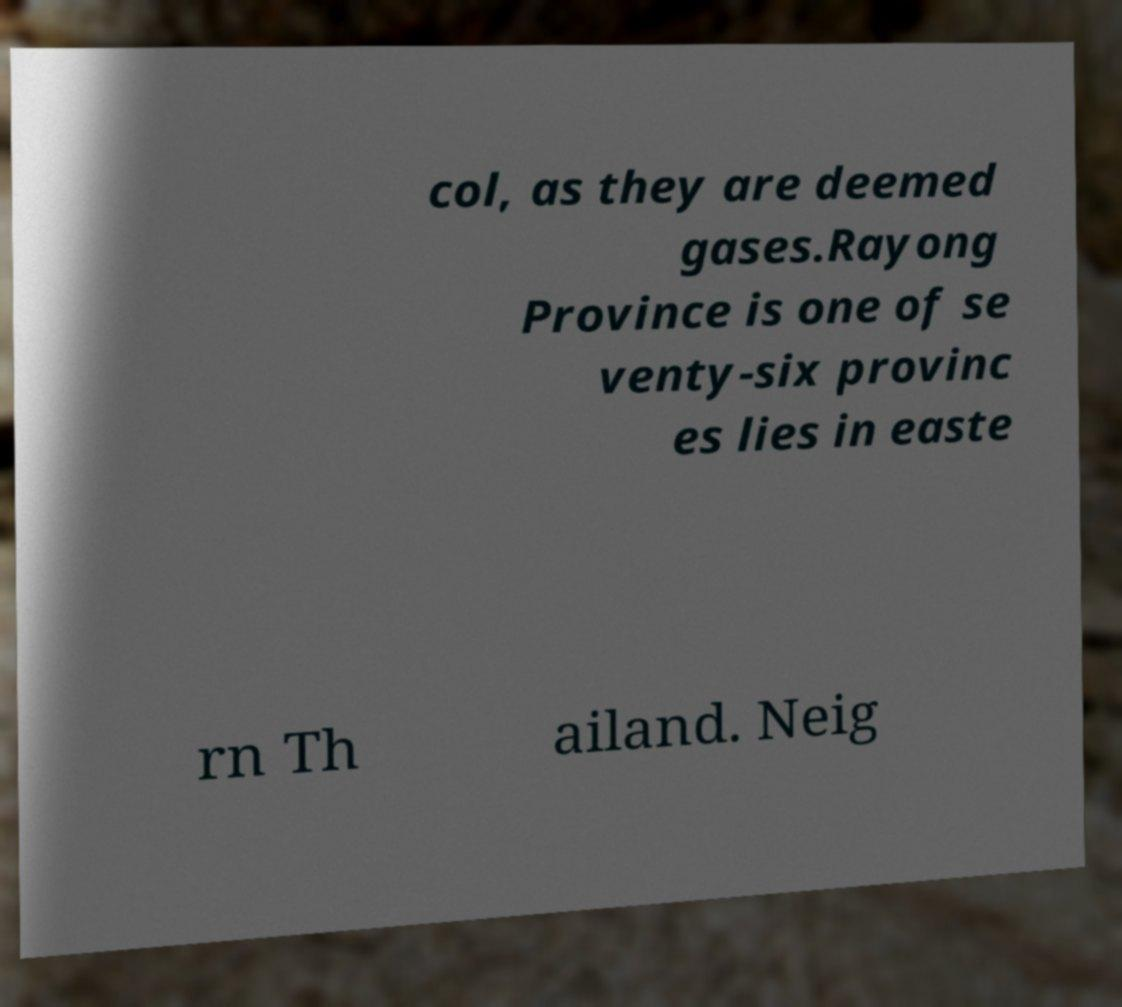Could you assist in decoding the text presented in this image and type it out clearly? col, as they are deemed gases.Rayong Province is one of se venty-six provinc es lies in easte rn Th ailand. Neig 